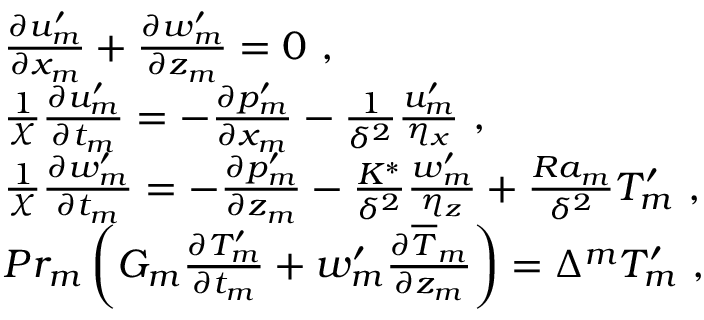Convert formula to latex. <formula><loc_0><loc_0><loc_500><loc_500>\begin{array} { r l } & { \frac { \partial { u } _ { m } ^ { \prime } } { \partial x _ { m } } + \frac { \partial { w } _ { m } ^ { \prime } } { \partial z _ { m } } = 0 , } \\ & { \frac { 1 } { \chi } \frac { \partial { u } _ { m } ^ { \prime } } { \partial t _ { m } } = - \frac { \partial { p } _ { m } ^ { \prime } } { \partial x _ { m } } - \frac { 1 } { \delta ^ { 2 } } \frac { { u } _ { m } ^ { \prime } } { \eta _ { x } } , } \\ & { \frac { 1 } { \chi } \frac { \partial { w } _ { m } ^ { \prime } } { \partial t _ { m } } = - \frac { \partial { p } _ { m } ^ { \prime } } { \partial z _ { m } } - \frac { K ^ { * } } { \delta ^ { 2 } } \frac { { w } _ { m } ^ { \prime } } { \eta _ { z } } + \frac { R a _ { m } } { \delta ^ { 2 } } { T } _ { m } ^ { \prime } , } \\ & { P r _ { m } \left ( G _ { m } \frac { \partial { T } _ { m } ^ { \prime } } { \partial t _ { m } } + { w } _ { m } ^ { \prime } \frac { \partial \overline { T } _ { m } } { \partial z _ { m } } \right ) = \Delta ^ { m } { T } _ { m } ^ { \prime } , } \end{array}</formula> 